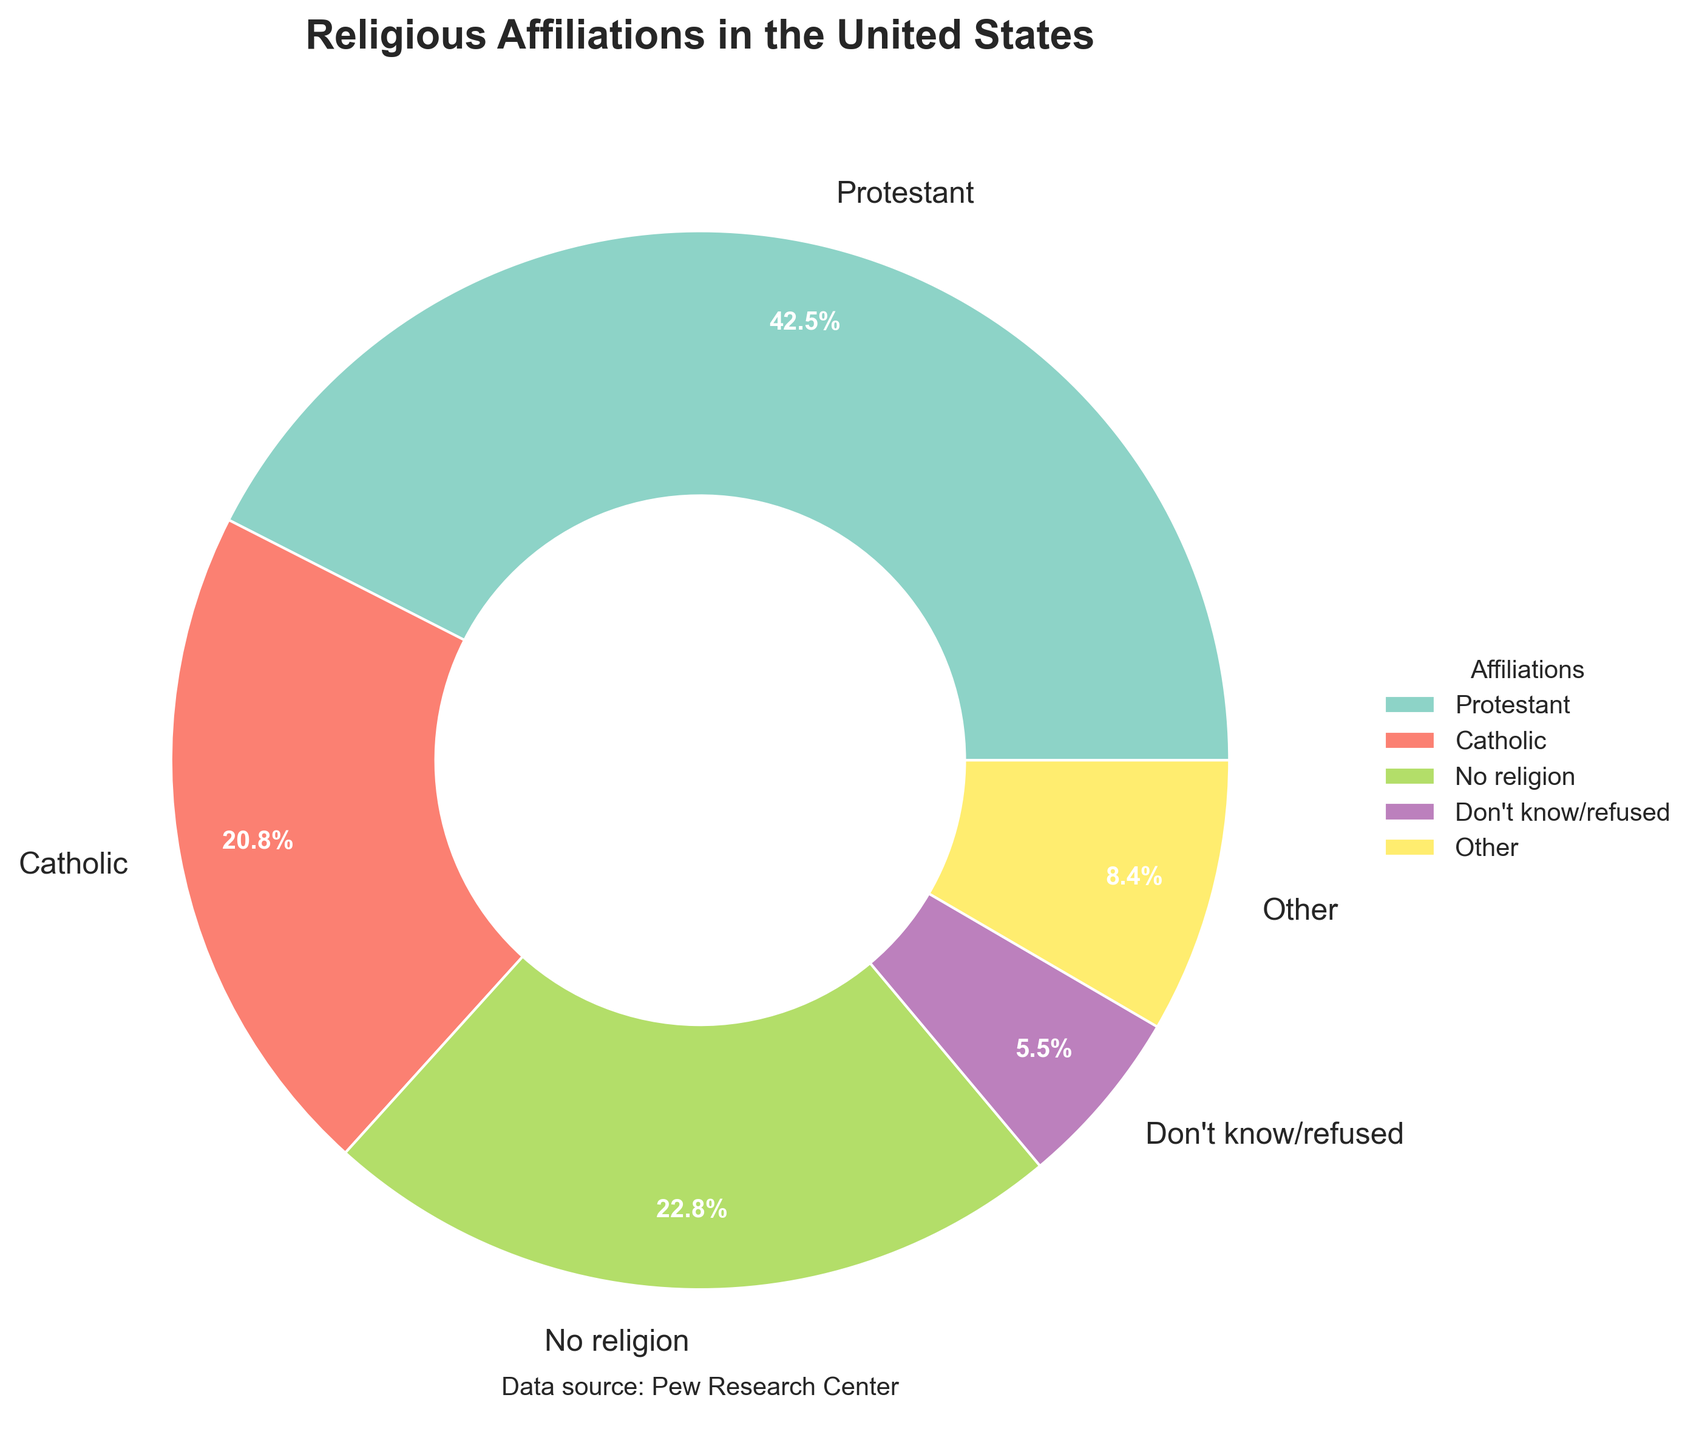Which group has the highest percentage of religious affiliation? The chart shows different religious affiliations and their percentages. Protestant has the largest section, indicated by the largest wedge in the pie chart.
Answer: Protestant What is the combined percentage of Catholic and No religion affiliations? The chart indicates Catholic at 20.8% and No religion at 22.8%. Adding these two gives: 20.8 + 22.8 = 43.6%
Answer: 43.6% Which groups have a percentage less than 2% individually? The chart shows several groups: Mormon, Jewish, Muslim, Hindu, Buddhist, Eastern Orthodox, Other Christian, Other world religions. Individually, their percentages are less than 2%.
Answer: Mormon, Jewish, Muslim, Hindu, Buddhist, Eastern Orthodox, Other Christian, Other world religions How much larger is the Protestant percentage compared to the Catholic percentage? The chart shows Protestant at 42.5% and Catholic at 20.8%. Subtracting Catholic from Protestant gives: 42.5 - 20.8 = 21.7%
Answer: 21.7% What is the percentage labeled as "Other"? The chart groups smaller affiliations into "Other". This combined "Other" category has a percentage of 2.4%.
Answer: 2.4% Which section is colored with the darkest color in the pie chart? In the pie chart, the Protestant section appears with the darkest color as it is the largest wedge.
Answer: Protestant What is the total percentage of affiliations less than 2% not grouped into "Other"? The chart lists individual groups under 2%: Mormon (1.6%), Jewish (1.9%), Other Christian (1.8%). Adding them gives: 1.6 + 1.9 + 1.8 = 5.3%
Answer: 5.3% How does the percentage of "Don't know/refused" compare to Eastern Orthodox? The chart shows "Don't know/refused" at 5.5% and Eastern Orthodox at 0.5%. "Don't know/refused" is 5.5 - 0.5 = 5% larger.
Answer: 5% Which religious affiliations along with "Other" compose the smallest visual sector in the chart? Groups with small percentages are combined into "Other", and individually small sections are: Mormon, Jewish, Muslim, Hindu, Buddhist, Eastern Orthodox, Other Christian, Other world religions. Together with "Other", they form the smallest visual sector.
Answer: Mormon, Jewish, Muslim, Hindu, Buddhist, Eastern Orthodox, Other Christian, Other world religions 